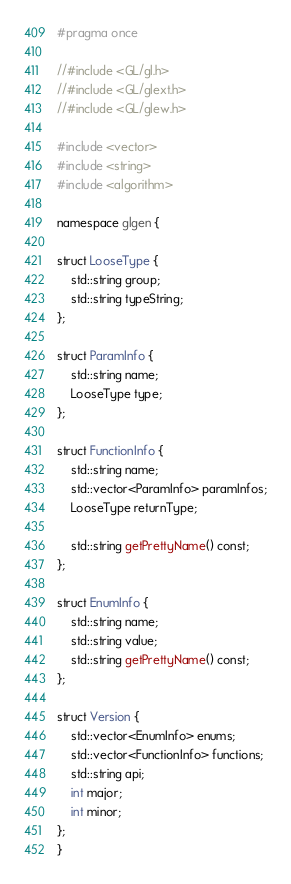<code> <loc_0><loc_0><loc_500><loc_500><_C++_>#pragma once

//#include <GL/gl.h>
//#include <GL/glext.h>
//#include <GL/glew.h>

#include <vector>
#include <string>
#include <algorithm>

namespace glgen {

struct LooseType {
	std::string group;
	std::string typeString;
};

struct ParamInfo {
	std::string name;
	LooseType type;
};

struct FunctionInfo {
	std::string name;
	std::vector<ParamInfo> paramInfos;
	LooseType returnType;

	std::string getPrettyName() const;
};

struct EnumInfo {
	std::string name;
	std::string value;
	std::string getPrettyName() const;
};

struct Version {
	std::vector<EnumInfo> enums;
	std::vector<FunctionInfo> functions;
	std::string api;
	int major;
	int minor;
};
}</code> 